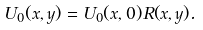<formula> <loc_0><loc_0><loc_500><loc_500>U _ { 0 } ( x , y ) = U _ { 0 } ( x , 0 ) R ( x , y ) .</formula> 